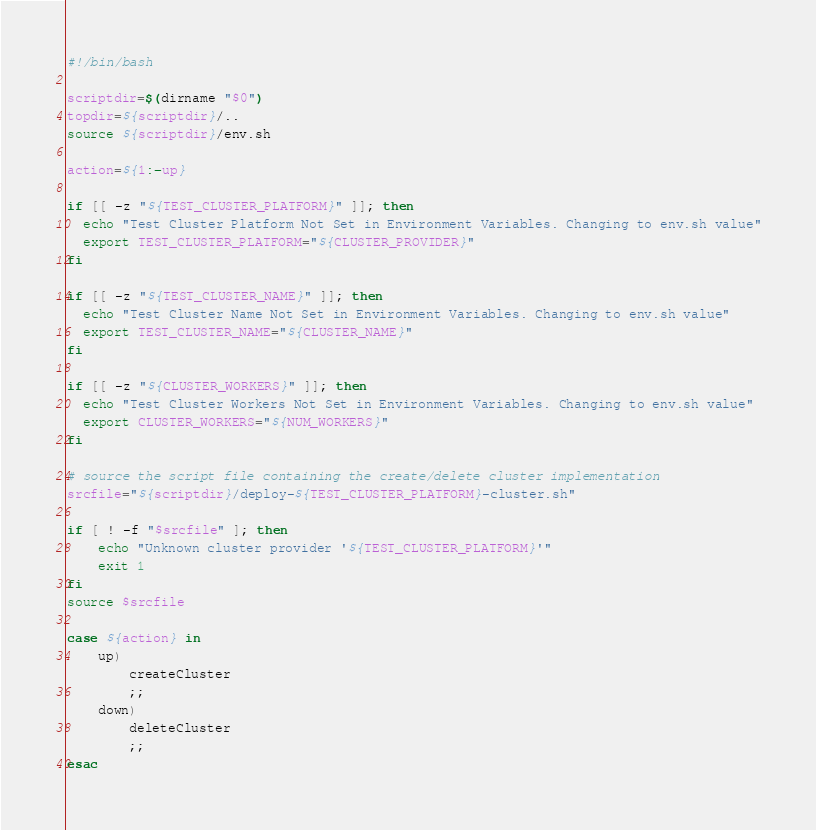Convert code to text. <code><loc_0><loc_0><loc_500><loc_500><_Bash_>#!/bin/bash

scriptdir=$(dirname "$0")
topdir=${scriptdir}/..
source ${scriptdir}/env.sh

action=${1:-up}

if [[ -z "${TEST_CLUSTER_PLATFORM}" ]]; then
  echo "Test Cluster Platform Not Set in Environment Variables. Changing to env.sh value"
  export TEST_CLUSTER_PLATFORM="${CLUSTER_PROVIDER}"
fi

if [[ -z "${TEST_CLUSTER_NAME}" ]]; then
  echo "Test Cluster Name Not Set in Environment Variables. Changing to env.sh value"
  export TEST_CLUSTER_NAME="${CLUSTER_NAME}"
fi

if [[ -z "${CLUSTER_WORKERS}" ]]; then
  echo "Test Cluster Workers Not Set in Environment Variables. Changing to env.sh value"
  export CLUSTER_WORKERS="${NUM_WORKERS}"
fi

# source the script file containing the create/delete cluster implementation
srcfile="${scriptdir}/deploy-${TEST_CLUSTER_PLATFORM}-cluster.sh"

if [ ! -f "$srcfile" ]; then
    echo "Unknown cluster provider '${TEST_CLUSTER_PLATFORM}'"
    exit 1
fi
source $srcfile

case ${action} in
    up)
        createCluster
        ;;
    down)
        deleteCluster
        ;;
esac
</code> 